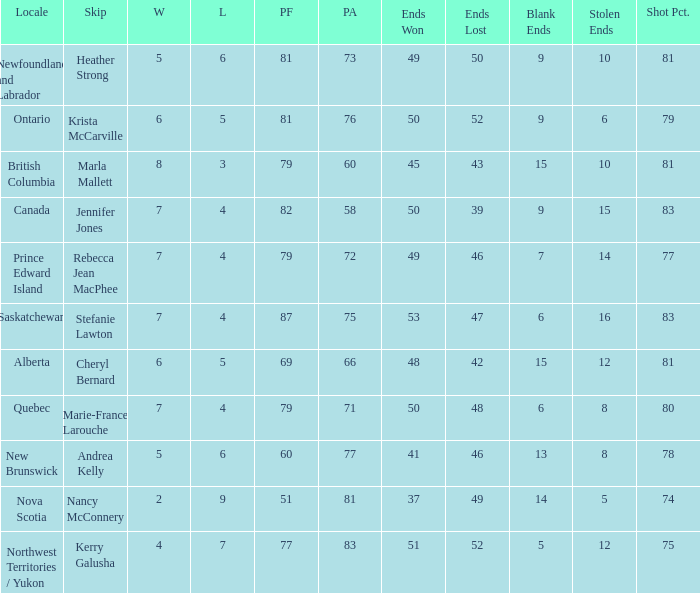Write the full table. {'header': ['Locale', 'Skip', 'W', 'L', 'PF', 'PA', 'Ends Won', 'Ends Lost', 'Blank Ends', 'Stolen Ends', 'Shot Pct.'], 'rows': [['Newfoundland and Labrador', 'Heather Strong', '5', '6', '81', '73', '49', '50', '9', '10', '81'], ['Ontario', 'Krista McCarville', '6', '5', '81', '76', '50', '52', '9', '6', '79'], ['British Columbia', 'Marla Mallett', '8', '3', '79', '60', '45', '43', '15', '10', '81'], ['Canada', 'Jennifer Jones', '7', '4', '82', '58', '50', '39', '9', '15', '83'], ['Prince Edward Island', 'Rebecca Jean MacPhee', '7', '4', '79', '72', '49', '46', '7', '14', '77'], ['Saskatchewan', 'Stefanie Lawton', '7', '4', '87', '75', '53', '47', '6', '16', '83'], ['Alberta', 'Cheryl Bernard', '6', '5', '69', '66', '48', '42', '15', '12', '81'], ['Quebec', 'Marie-France Larouche', '7', '4', '79', '71', '50', '48', '6', '8', '80'], ['New Brunswick', 'Andrea Kelly', '5', '6', '60', '77', '41', '46', '13', '8', '78'], ['Nova Scotia', 'Nancy McConnery', '2', '9', '51', '81', '37', '49', '14', '5', '74'], ['Northwest Territories / Yukon', 'Kerry Galusha', '4', '7', '77', '83', '51', '52', '5', '12', '75']]} What is the pf for Rebecca Jean Macphee? 79.0. 